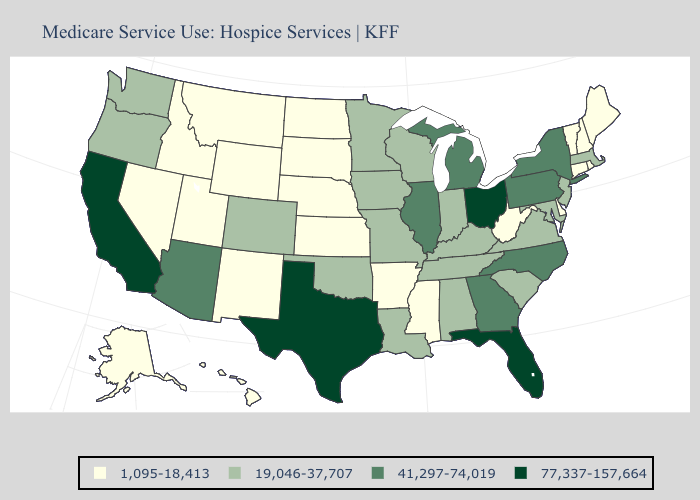What is the value of New Mexico?
Quick response, please. 1,095-18,413. Name the states that have a value in the range 77,337-157,664?
Short answer required. California, Florida, Ohio, Texas. Does Colorado have the lowest value in the West?
Give a very brief answer. No. Does South Dakota have the lowest value in the MidWest?
Write a very short answer. Yes. Does Colorado have the highest value in the USA?
Give a very brief answer. No. What is the highest value in the West ?
Be succinct. 77,337-157,664. Is the legend a continuous bar?
Answer briefly. No. What is the value of Indiana?
Keep it brief. 19,046-37,707. Does Pennsylvania have a lower value than Texas?
Concise answer only. Yes. Name the states that have a value in the range 41,297-74,019?
Quick response, please. Arizona, Georgia, Illinois, Michigan, New York, North Carolina, Pennsylvania. What is the lowest value in the USA?
Answer briefly. 1,095-18,413. What is the value of Florida?
Keep it brief. 77,337-157,664. What is the value of Maine?
Quick response, please. 1,095-18,413. Which states have the highest value in the USA?
Short answer required. California, Florida, Ohio, Texas. Does Tennessee have a higher value than Michigan?
Answer briefly. No. 